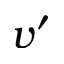Convert formula to latex. <formula><loc_0><loc_0><loc_500><loc_500>v ^ { \prime }</formula> 